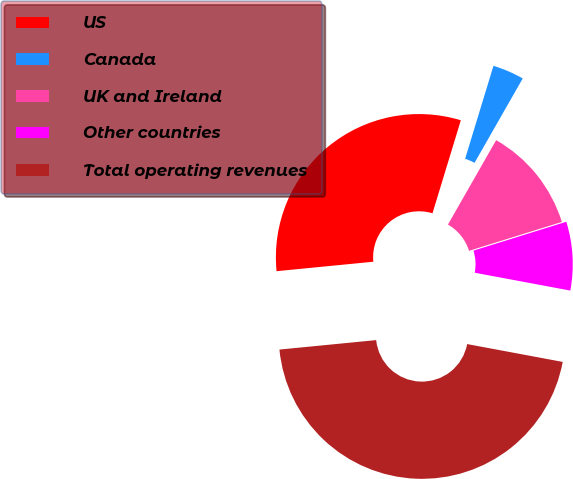Convert chart to OTSL. <chart><loc_0><loc_0><loc_500><loc_500><pie_chart><fcel>US<fcel>Canada<fcel>UK and Ireland<fcel>Other countries<fcel>Total operating revenues<nl><fcel>31.26%<fcel>3.55%<fcel>11.94%<fcel>7.74%<fcel>45.51%<nl></chart> 